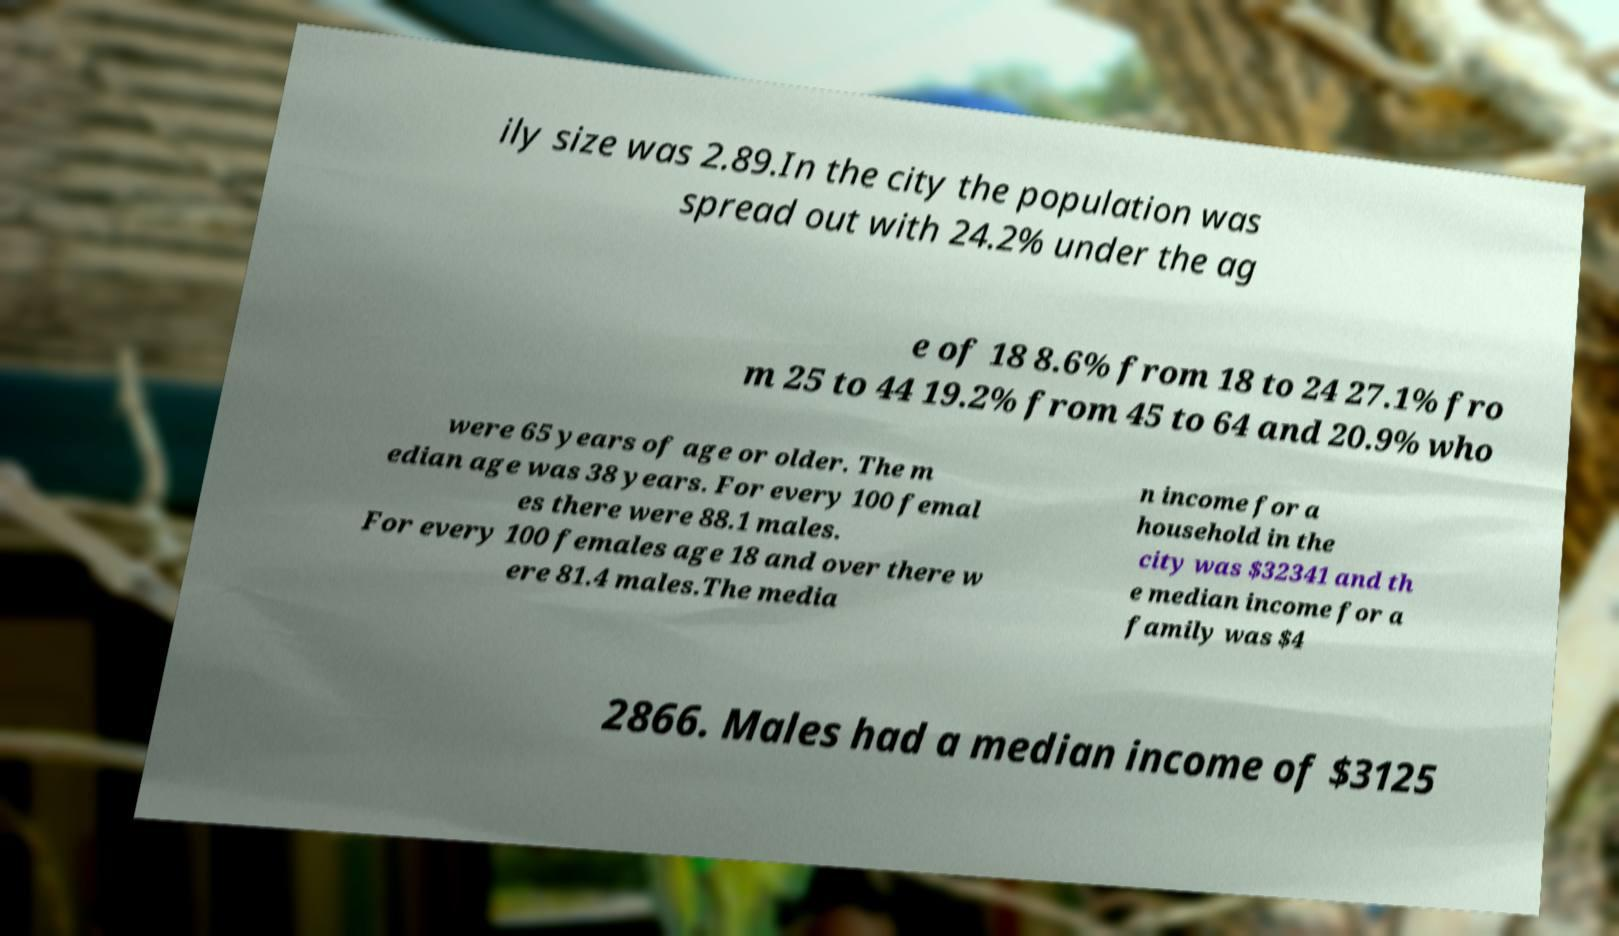There's text embedded in this image that I need extracted. Can you transcribe it verbatim? ily size was 2.89.In the city the population was spread out with 24.2% under the ag e of 18 8.6% from 18 to 24 27.1% fro m 25 to 44 19.2% from 45 to 64 and 20.9% who were 65 years of age or older. The m edian age was 38 years. For every 100 femal es there were 88.1 males. For every 100 females age 18 and over there w ere 81.4 males.The media n income for a household in the city was $32341 and th e median income for a family was $4 2866. Males had a median income of $3125 